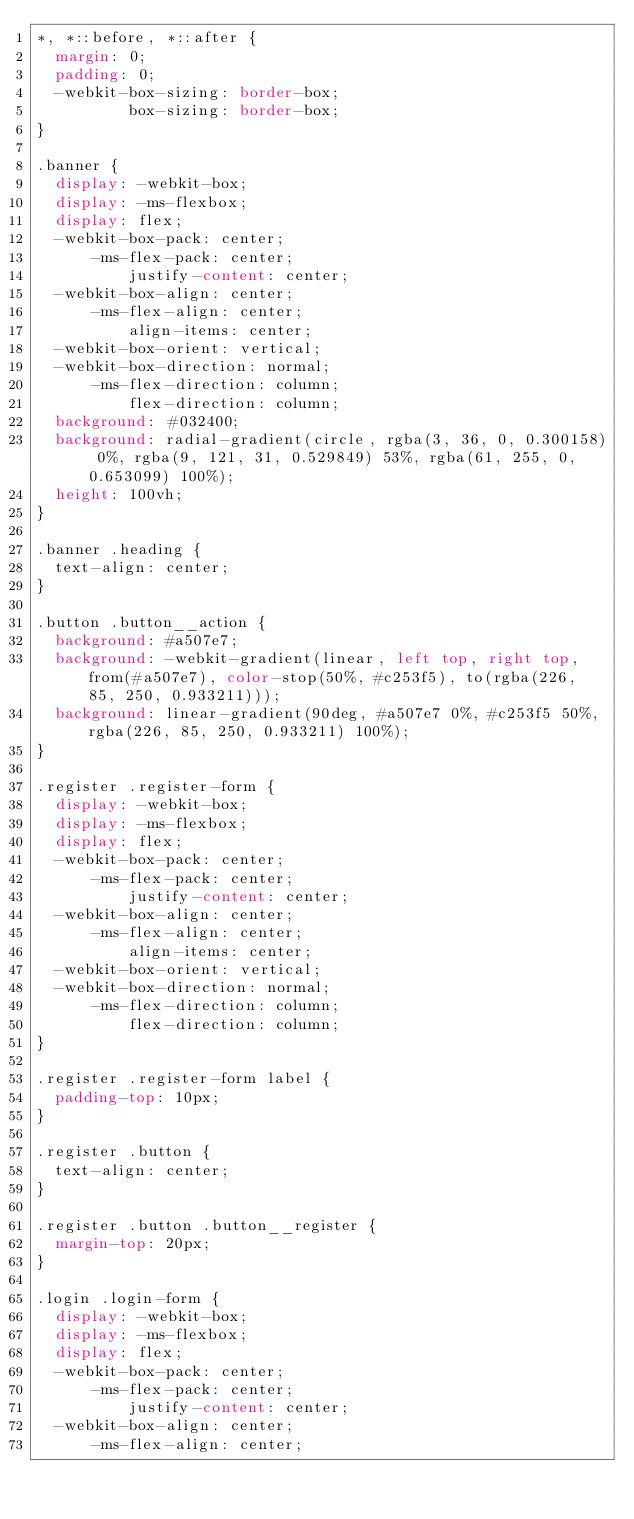<code> <loc_0><loc_0><loc_500><loc_500><_CSS_>*, *::before, *::after {
  margin: 0;
  padding: 0;
  -webkit-box-sizing: border-box;
          box-sizing: border-box;
}

.banner {
  display: -webkit-box;
  display: -ms-flexbox;
  display: flex;
  -webkit-box-pack: center;
      -ms-flex-pack: center;
          justify-content: center;
  -webkit-box-align: center;
      -ms-flex-align: center;
          align-items: center;
  -webkit-box-orient: vertical;
  -webkit-box-direction: normal;
      -ms-flex-direction: column;
          flex-direction: column;
  background: #032400;
  background: radial-gradient(circle, rgba(3, 36, 0, 0.300158) 0%, rgba(9, 121, 31, 0.529849) 53%, rgba(61, 255, 0, 0.653099) 100%);
  height: 100vh;
}

.banner .heading {
  text-align: center;
}

.button .button__action {
  background: #a507e7;
  background: -webkit-gradient(linear, left top, right top, from(#a507e7), color-stop(50%, #c253f5), to(rgba(226, 85, 250, 0.933211)));
  background: linear-gradient(90deg, #a507e7 0%, #c253f5 50%, rgba(226, 85, 250, 0.933211) 100%);
}

.register .register-form {
  display: -webkit-box;
  display: -ms-flexbox;
  display: flex;
  -webkit-box-pack: center;
      -ms-flex-pack: center;
          justify-content: center;
  -webkit-box-align: center;
      -ms-flex-align: center;
          align-items: center;
  -webkit-box-orient: vertical;
  -webkit-box-direction: normal;
      -ms-flex-direction: column;
          flex-direction: column;
}

.register .register-form label {
  padding-top: 10px;
}

.register .button {
  text-align: center;
}

.register .button .button__register {
  margin-top: 20px;
}

.login .login-form {
  display: -webkit-box;
  display: -ms-flexbox;
  display: flex;
  -webkit-box-pack: center;
      -ms-flex-pack: center;
          justify-content: center;
  -webkit-box-align: center;
      -ms-flex-align: center;</code> 